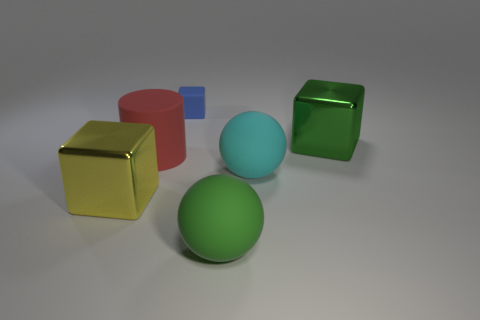Can you tell me about the lighting in this scene? The lighting in the image appears to be diffused with soft shadows, suggesting an overhead light source that provides a gentle illumination on the objects without creating harsh shadows. 